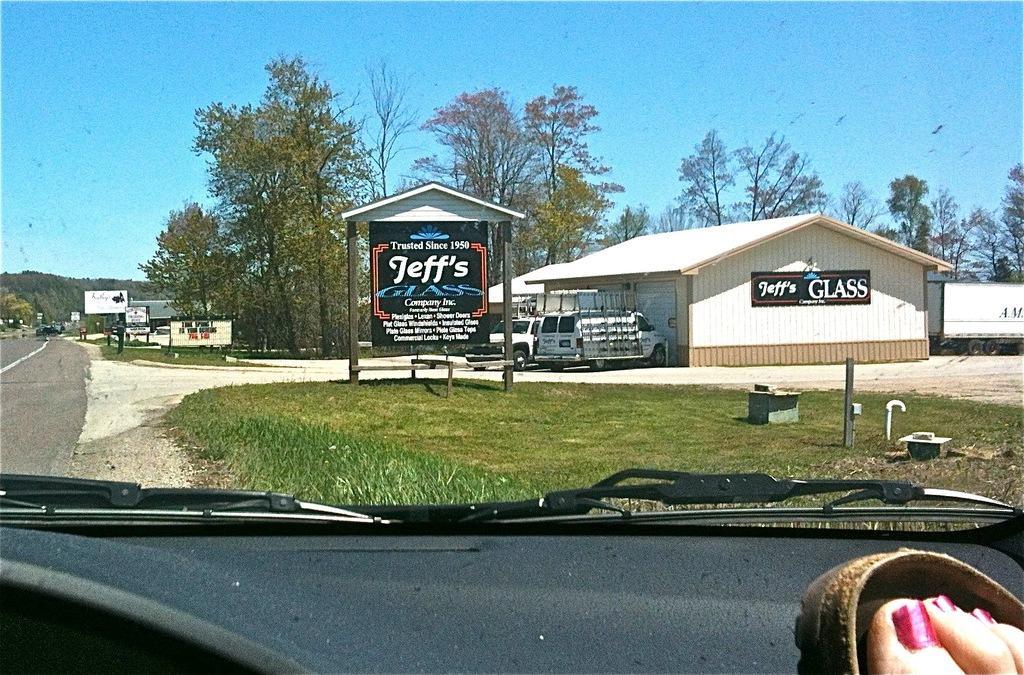Please provide a concise description of this image. In this picture we can see a person leg inside a vehicle, grass, road, vehicles, name boards, banners, trees, houses and some objects and in the background we can see the sky. 